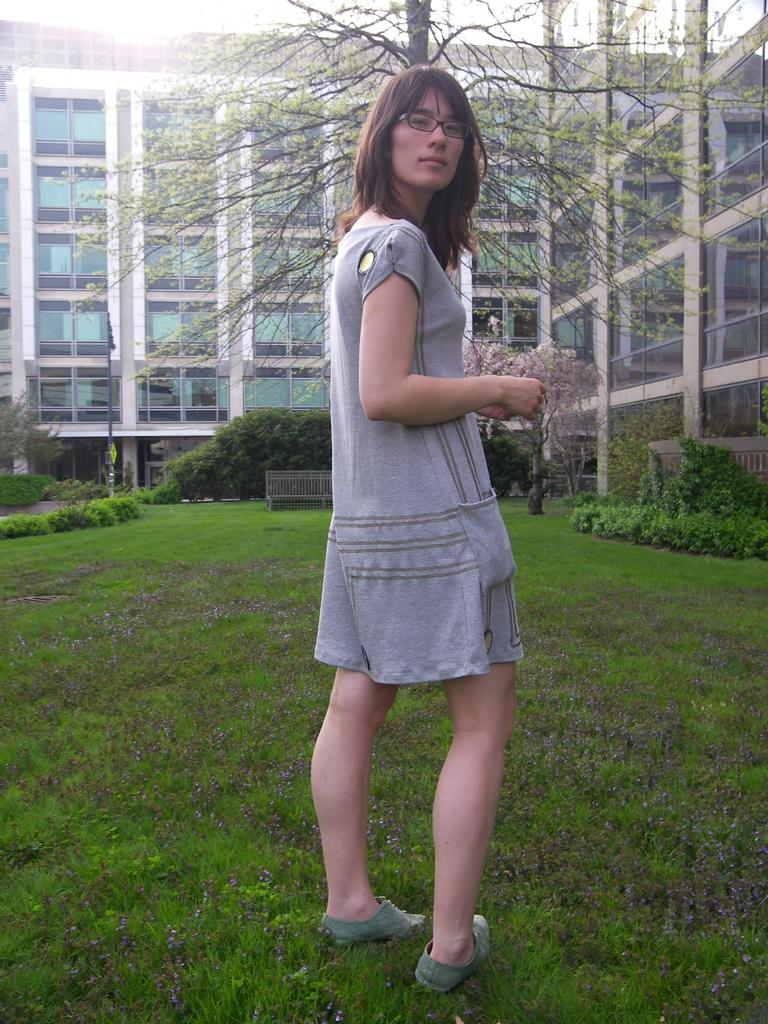Who is the main subject in the image? There is a woman standing in the center of the image. What is the woman standing on? The woman is standing on the grass. What can be seen in the background of the image? There are buildings, trees, a pole, and the sky visible in the background of the image. What type of riddle is the woman holding in her hand in the image? There is no riddle visible in the woman's hand in the image. How many roses can be seen near the woman in the image? There are no roses present in the image. 